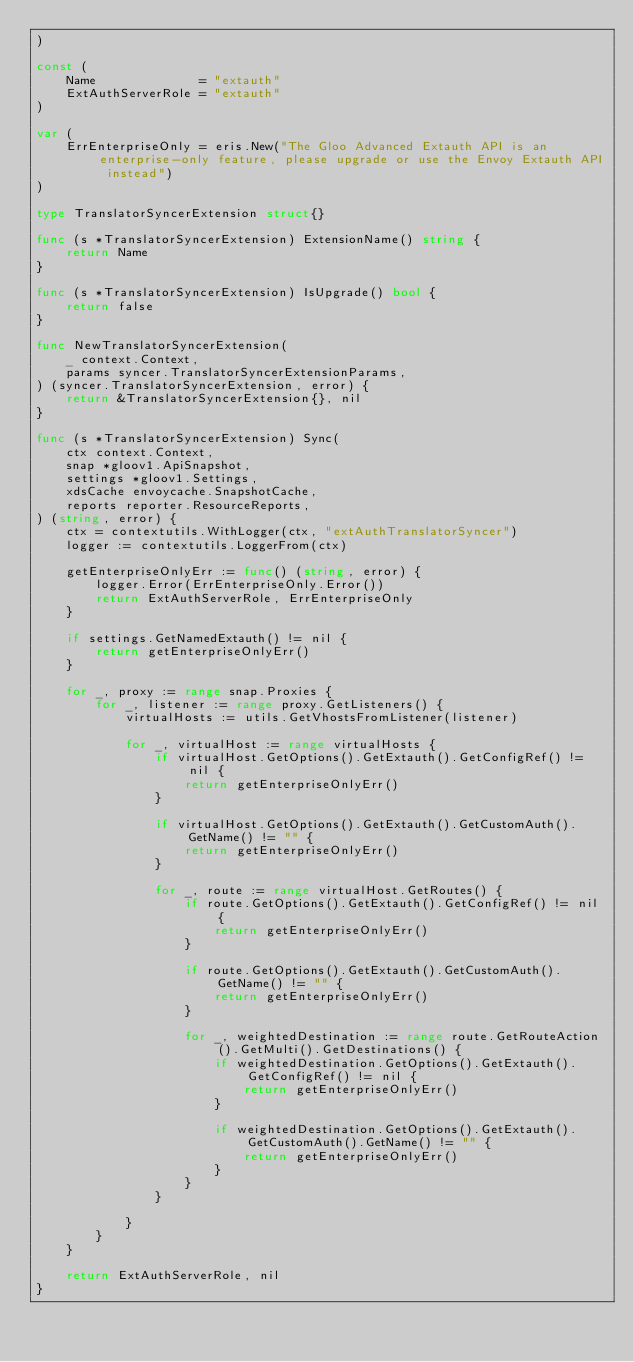<code> <loc_0><loc_0><loc_500><loc_500><_Go_>)

const (
	Name              = "extauth"
	ExtAuthServerRole = "extauth"
)

var (
	ErrEnterpriseOnly = eris.New("The Gloo Advanced Extauth API is an enterprise-only feature, please upgrade or use the Envoy Extauth API instead")
)

type TranslatorSyncerExtension struct{}

func (s *TranslatorSyncerExtension) ExtensionName() string {
	return Name
}

func (s *TranslatorSyncerExtension) IsUpgrade() bool {
	return false
}

func NewTranslatorSyncerExtension(
	_ context.Context,
	params syncer.TranslatorSyncerExtensionParams,
) (syncer.TranslatorSyncerExtension, error) {
	return &TranslatorSyncerExtension{}, nil
}

func (s *TranslatorSyncerExtension) Sync(
	ctx context.Context,
	snap *gloov1.ApiSnapshot,
	settings *gloov1.Settings,
	xdsCache envoycache.SnapshotCache,
	reports reporter.ResourceReports,
) (string, error) {
	ctx = contextutils.WithLogger(ctx, "extAuthTranslatorSyncer")
	logger := contextutils.LoggerFrom(ctx)

	getEnterpriseOnlyErr := func() (string, error) {
		logger.Error(ErrEnterpriseOnly.Error())
		return ExtAuthServerRole, ErrEnterpriseOnly
	}

	if settings.GetNamedExtauth() != nil {
		return getEnterpriseOnlyErr()
	}

	for _, proxy := range snap.Proxies {
		for _, listener := range proxy.GetListeners() {
			virtualHosts := utils.GetVhostsFromListener(listener)

			for _, virtualHost := range virtualHosts {
				if virtualHost.GetOptions().GetExtauth().GetConfigRef() != nil {
					return getEnterpriseOnlyErr()
				}

				if virtualHost.GetOptions().GetExtauth().GetCustomAuth().GetName() != "" {
					return getEnterpriseOnlyErr()
				}

				for _, route := range virtualHost.GetRoutes() {
					if route.GetOptions().GetExtauth().GetConfigRef() != nil {
						return getEnterpriseOnlyErr()
					}

					if route.GetOptions().GetExtauth().GetCustomAuth().GetName() != "" {
						return getEnterpriseOnlyErr()
					}

					for _, weightedDestination := range route.GetRouteAction().GetMulti().GetDestinations() {
						if weightedDestination.GetOptions().GetExtauth().GetConfigRef() != nil {
							return getEnterpriseOnlyErr()
						}

						if weightedDestination.GetOptions().GetExtauth().GetCustomAuth().GetName() != "" {
							return getEnterpriseOnlyErr()
						}
					}
				}

			}
		}
	}

	return ExtAuthServerRole, nil
}
</code> 